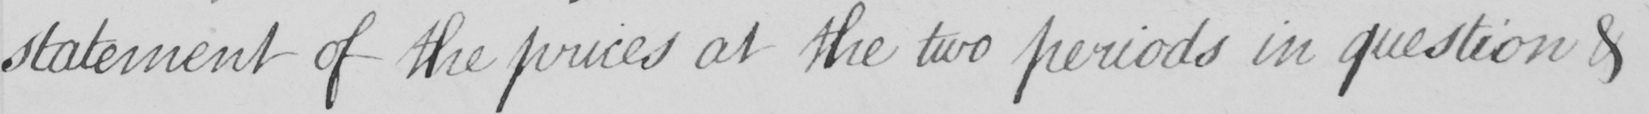Please provide the text content of this handwritten line. statement of the prices at the two periods in question & 